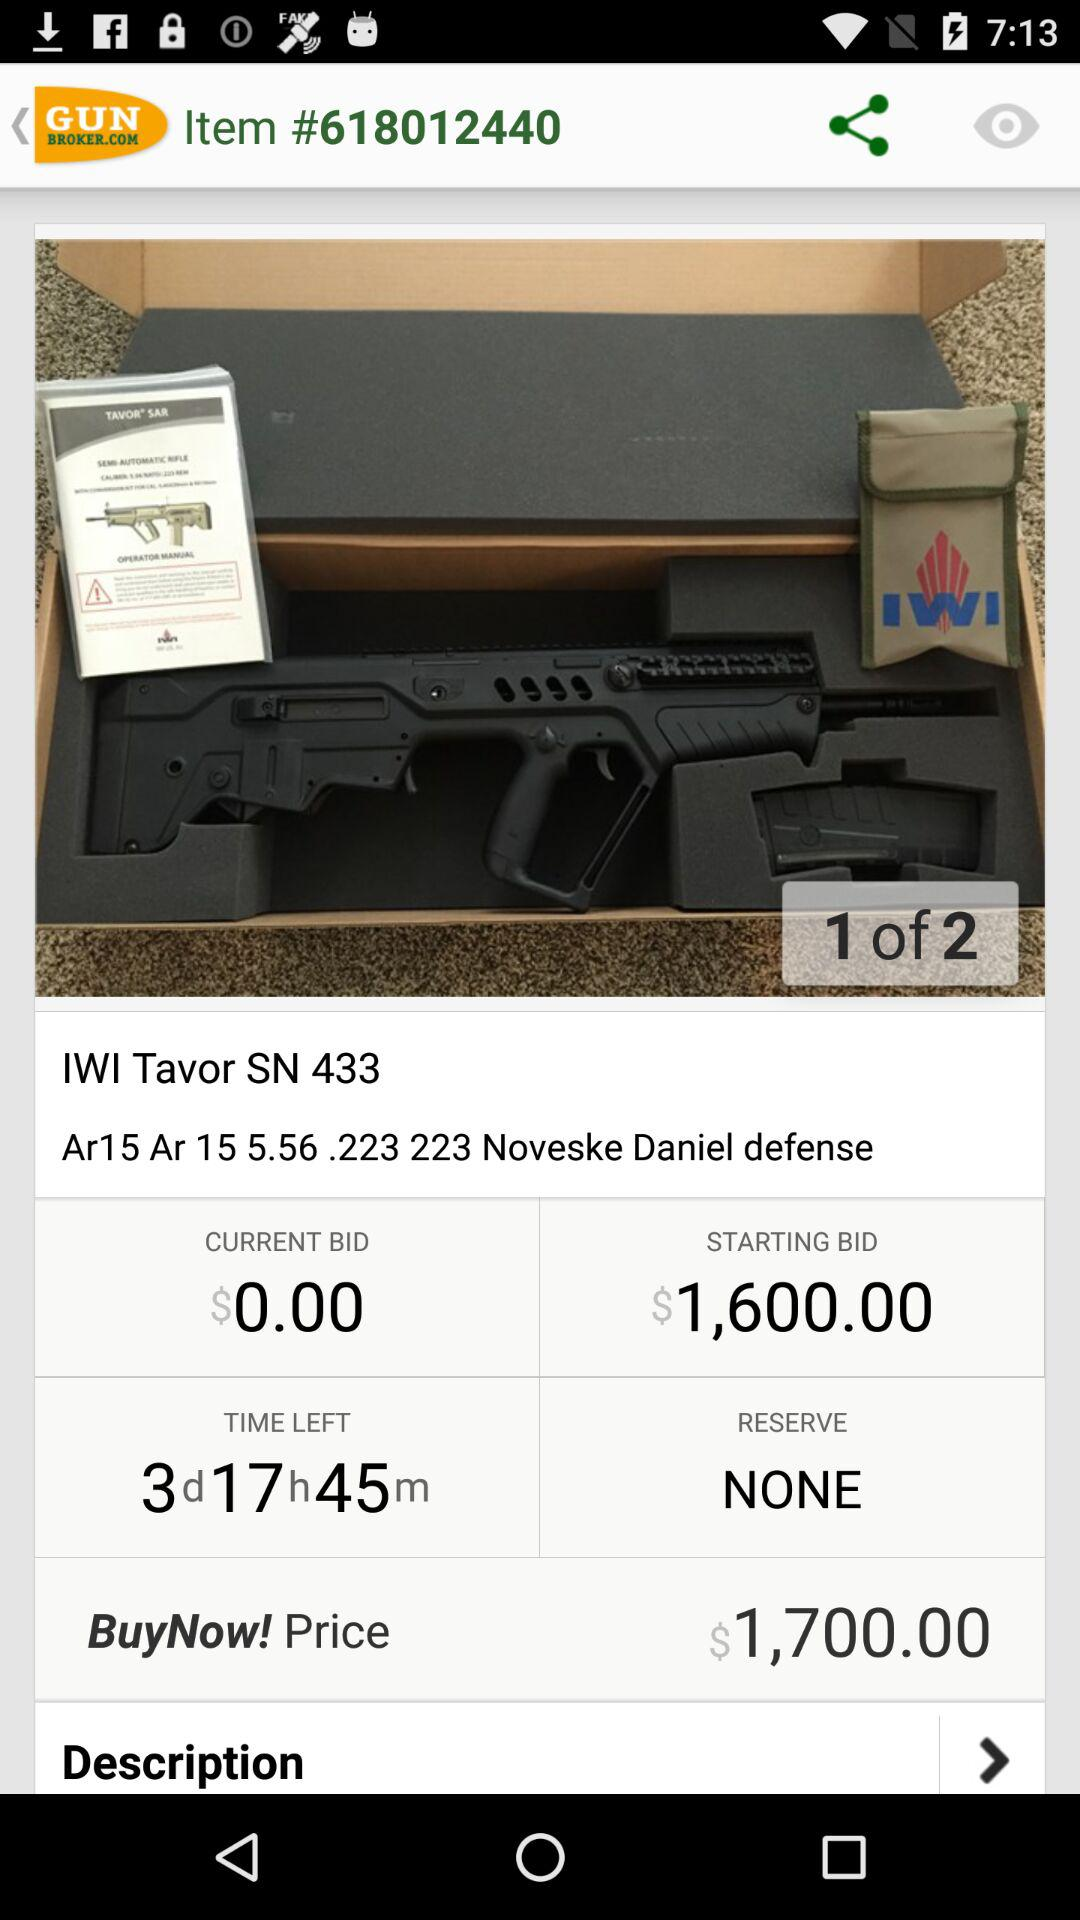What is the current bid? The current bid is $0. 